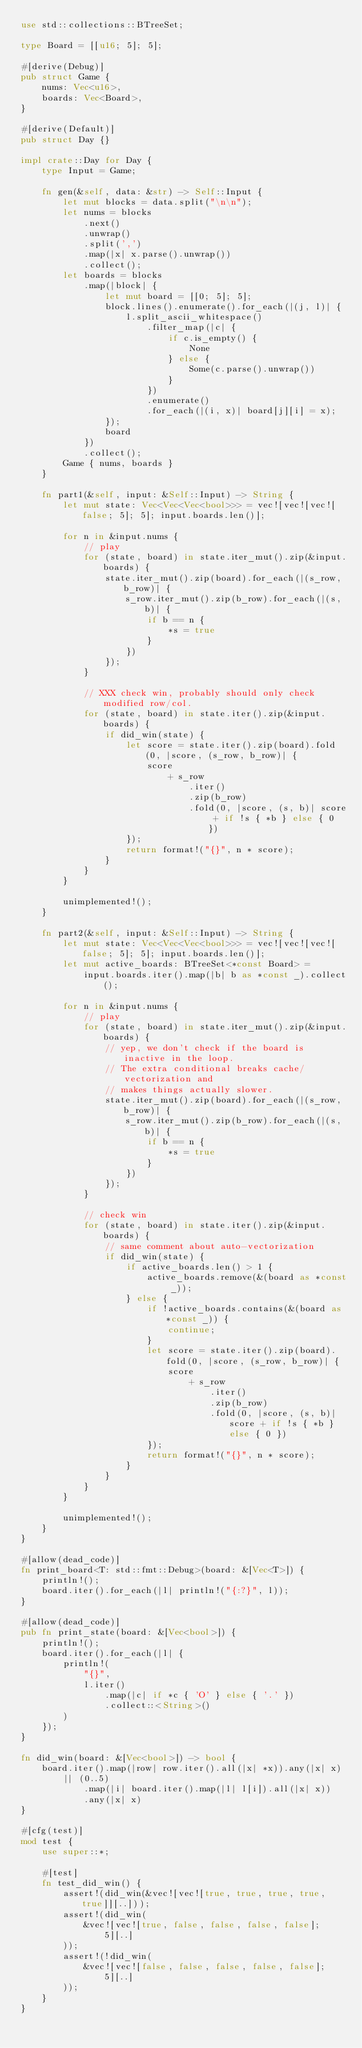Convert code to text. <code><loc_0><loc_0><loc_500><loc_500><_Rust_>use std::collections::BTreeSet;

type Board = [[u16; 5]; 5];

#[derive(Debug)]
pub struct Game {
    nums: Vec<u16>,
    boards: Vec<Board>,
}

#[derive(Default)]
pub struct Day {}

impl crate::Day for Day {
    type Input = Game;

    fn gen(&self, data: &str) -> Self::Input {
        let mut blocks = data.split("\n\n");
        let nums = blocks
            .next()
            .unwrap()
            .split(',')
            .map(|x| x.parse().unwrap())
            .collect();
        let boards = blocks
            .map(|block| {
                let mut board = [[0; 5]; 5];
                block.lines().enumerate().for_each(|(j, l)| {
                    l.split_ascii_whitespace()
                        .filter_map(|c| {
                            if c.is_empty() {
                                None
                            } else {
                                Some(c.parse().unwrap())
                            }
                        })
                        .enumerate()
                        .for_each(|(i, x)| board[j][i] = x);
                });
                board
            })
            .collect();
        Game { nums, boards }
    }

    fn part1(&self, input: &Self::Input) -> String {
        let mut state: Vec<Vec<Vec<bool>>> = vec![vec![vec![false; 5]; 5]; input.boards.len()];

        for n in &input.nums {
            // play
            for (state, board) in state.iter_mut().zip(&input.boards) {
                state.iter_mut().zip(board).for_each(|(s_row, b_row)| {
                    s_row.iter_mut().zip(b_row).for_each(|(s, b)| {
                        if b == n {
                            *s = true
                        }
                    })
                });
            }

            // XXX check win, probably should only check modified row/col.
            for (state, board) in state.iter().zip(&input.boards) {
                if did_win(state) {
                    let score = state.iter().zip(board).fold(0, |score, (s_row, b_row)| {
                        score
                            + s_row
                                .iter()
                                .zip(b_row)
                                .fold(0, |score, (s, b)| score + if !s { *b } else { 0 })
                    });
                    return format!("{}", n * score);
                }
            }
        }

        unimplemented!();
    }

    fn part2(&self, input: &Self::Input) -> String {
        let mut state: Vec<Vec<Vec<bool>>> = vec![vec![vec![false; 5]; 5]; input.boards.len()];
        let mut active_boards: BTreeSet<*const Board> =
            input.boards.iter().map(|b| b as *const _).collect();

        for n in &input.nums {
            // play
            for (state, board) in state.iter_mut().zip(&input.boards) {
                // yep, we don't check if the board is inactive in the loop.
                // The extra conditional breaks cache/vectorization and
                // makes things actually slower.
                state.iter_mut().zip(board).for_each(|(s_row, b_row)| {
                    s_row.iter_mut().zip(b_row).for_each(|(s, b)| {
                        if b == n {
                            *s = true
                        }
                    })
                });
            }

            // check win
            for (state, board) in state.iter().zip(&input.boards) {
                // same comment about auto-vectorization
                if did_win(state) {
                    if active_boards.len() > 1 {
                        active_boards.remove(&(board as *const _));
                    } else {
                        if !active_boards.contains(&(board as *const _)) {
                            continue;
                        }
                        let score = state.iter().zip(board).fold(0, |score, (s_row, b_row)| {
                            score
                                + s_row
                                    .iter()
                                    .zip(b_row)
                                    .fold(0, |score, (s, b)| score + if !s { *b } else { 0 })
                        });
                        return format!("{}", n * score);
                    }
                }
            }
        }

        unimplemented!();
    }
}

#[allow(dead_code)]
fn print_board<T: std::fmt::Debug>(board: &[Vec<T>]) {
    println!();
    board.iter().for_each(|l| println!("{:?}", l));
}

#[allow(dead_code)]
pub fn print_state(board: &[Vec<bool>]) {
    println!();
    board.iter().for_each(|l| {
        println!(
            "{}",
            l.iter()
                .map(|c| if *c { 'O' } else { '.' })
                .collect::<String>()
        )
    });
}

fn did_win(board: &[Vec<bool>]) -> bool {
    board.iter().map(|row| row.iter().all(|x| *x)).any(|x| x)
        || (0..5)
            .map(|i| board.iter().map(|l| l[i]).all(|x| x))
            .any(|x| x)
}

#[cfg(test)]
mod test {
    use super::*;

    #[test]
    fn test_did_win() {
        assert!(did_win(&vec![vec![true, true, true, true, true]][..]));
        assert!(did_win(
            &vec![vec![true, false, false, false, false]; 5][..]
        ));
        assert!(!did_win(
            &vec![vec![false, false, false, false, false]; 5][..]
        ));
    }
}
</code> 